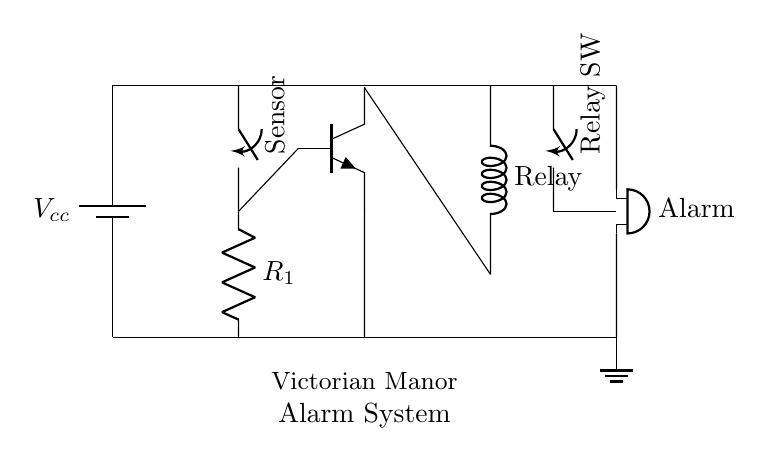What is the power supply in the circuit? The power supply is represented by a battery symbol, indicated as \( V_{cc} \), which provides the necessary voltage for the circuit components.
Answer: Vcc What component acts as the intrusion detector? The intrusion detector is represented by a switch symbol labeled "Sensor," indicating that it detects electromagnetic changes and opens or closes the circuit in response.
Answer: Sensor How many resistors are present in the circuit? There is one resistor symbol present, labeled as \( R_1 \), connected in series with the sensor switch before the transistor.
Answer: 1 What component activates the alarm? The alarm is activated by the buzzer symbol, which is connected to the relay and will sound when the circuit is closed due to an intrusion.
Answer: Alarm What is the role of the transistor in this circuit? The transistor acts as a switch or amplifier, controlling the relay based on the state of the sensor; when the sensor is triggered, the transistor allows current to flow to the relay to activate the alarm system.
Answer: Switch What is the function of the relay in this circuit? The relay functions as an electrically operated switch that allows low-power signals from the transistor to control the higher power circuit for the alarm, thereby enabling the alarm to sound when triggered.
Answer: Electrically operated switch What would happen if the sensor is triggered? If the sensor is triggered, it closes the circuit allowing the current to flow through the resistor to the base of the transistor, causing it to turn on, which in turn activates the relay and sounds the alarm.
Answer: Alarm sounds 